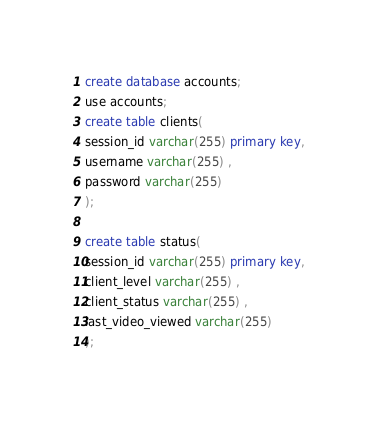<code> <loc_0><loc_0><loc_500><loc_500><_SQL_>create database accounts; 
use accounts; 
create table clients(
session_id varchar(255) primary key,   
username varchar(255) , 
password varchar(255)
);

create table status(
session_id varchar(255) primary key,   
client_level varchar(255) , 
client_status varchar(255) ,
last_video_viewed varchar(255)
);</code> 